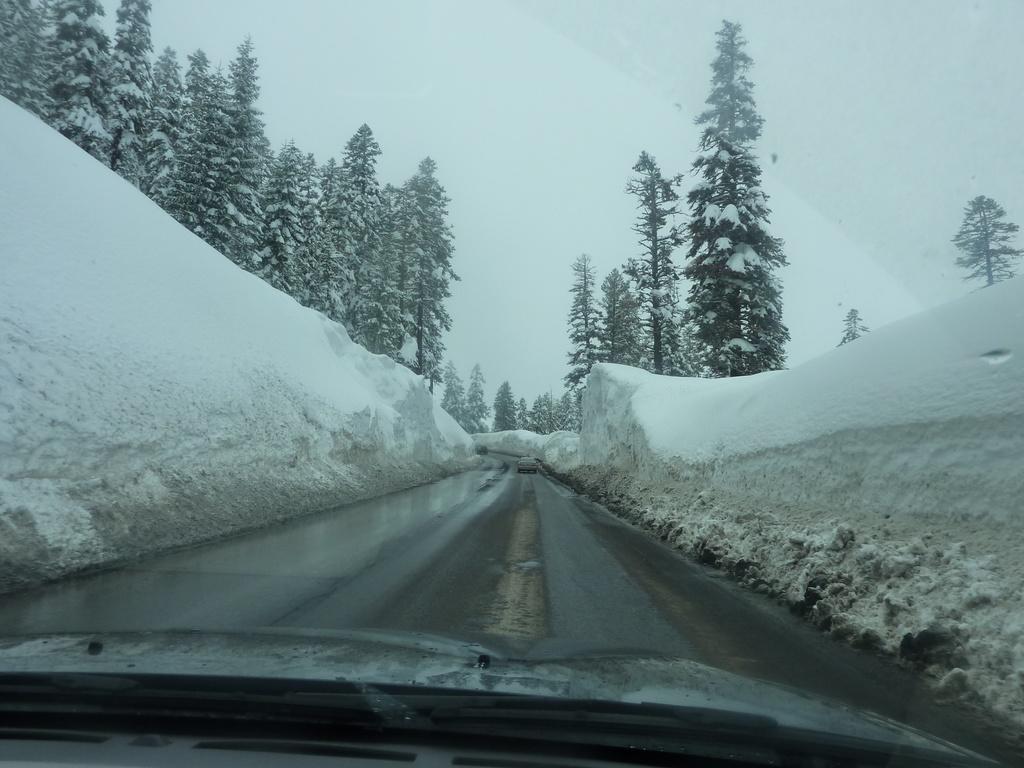In one or two sentences, can you explain what this image depicts? In this image there is a road. There are snow walls on the both sides. There are trees and snow. There are mountains in the background. 